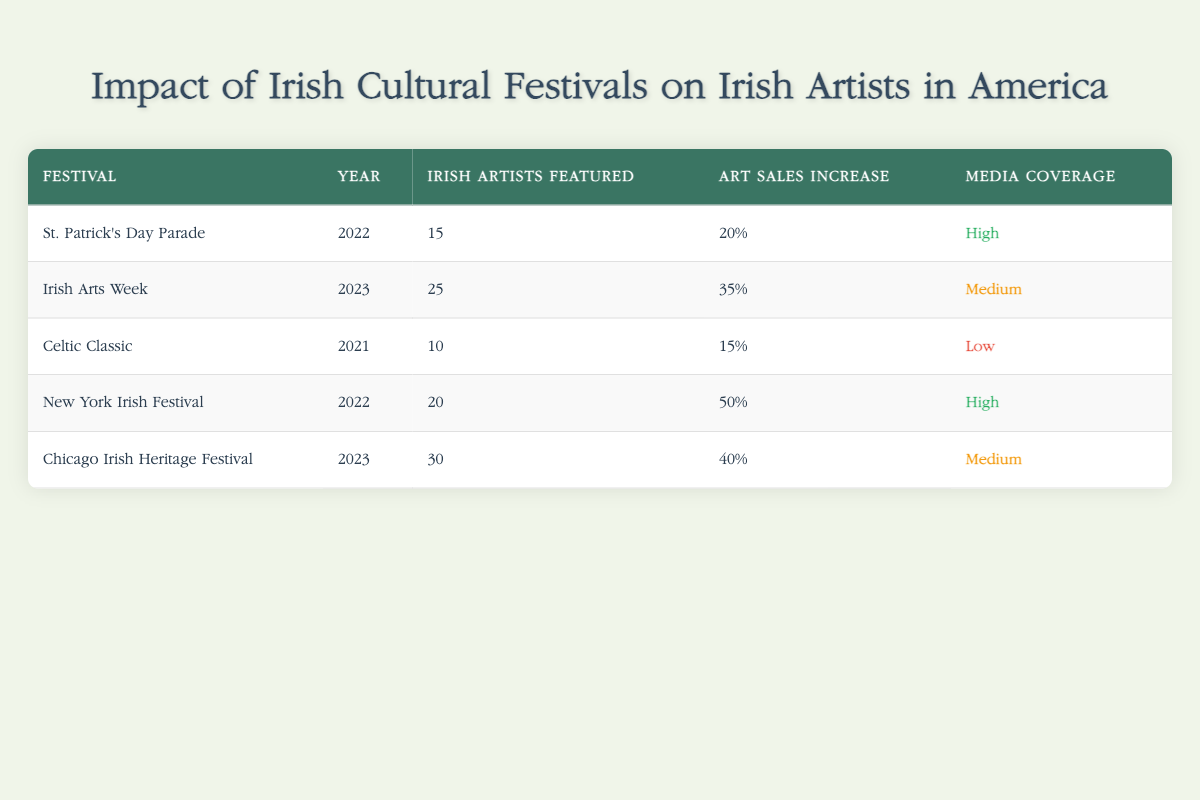What is the number of Irish artists featured at the Chicago Irish Heritage Festival in 2023? The Chicago Irish Heritage Festival in 2023 has the row details that state it featured 30 Irish artists.
Answer: 30 What is the art sales increase percentage for the New York Irish Festival in 2022? The New York Irish Festival in 2022 has a row that shows an art sales increase percentage of 50%.
Answer: 50% Did the Celtic Classic have high visibility media coverage? The table indicates that the Celtic Classic had "Low" media coverage, as specified in the row for that festival.
Answer: No What is the total number of Irish artists featured across all festivals in 2023? The Irish Arts Week featured 25 artists and the Chicago Irish Heritage Festival featured 30 artists in 2023. Adding these gives a total of 25 + 30 = 55.
Answer: 55 How does the art sales increase percentage for Irish Arts Week in 2023 compare to that of St. Patrick's Day Parade in 2022? Irish Arts Week in 2023 has an art sales increase of 35%, while St. Patrick's Day Parade in 2022 has an increase of 20%. The comparison shows that 35% is greater than 20%.
Answer: Greater What is the average number of Irish artists featured at the events listed in 2022? The events in 2022 are the St. Patrick's Day Parade with 15 artists and the New York Irish Festival with 20 artists. To find the average: (15 + 20) / 2 = 17.5.
Answer: 17.5 Which festival had the highest percentage increase in art sales? Looking at the percentages, the New York Irish Festival in 2022 had the highest art sales increase with 50%.
Answer: New York Irish Festival What percentage of festivals featured "High" media coverage? The St. Patrick's Day Parade and the New York Irish Festival both had "High" visibility media coverage. Therefore, 2 out of the 5 festivals have high media coverage, which gives a percentage of (2/5) * 100 = 40%.
Answer: 40% 